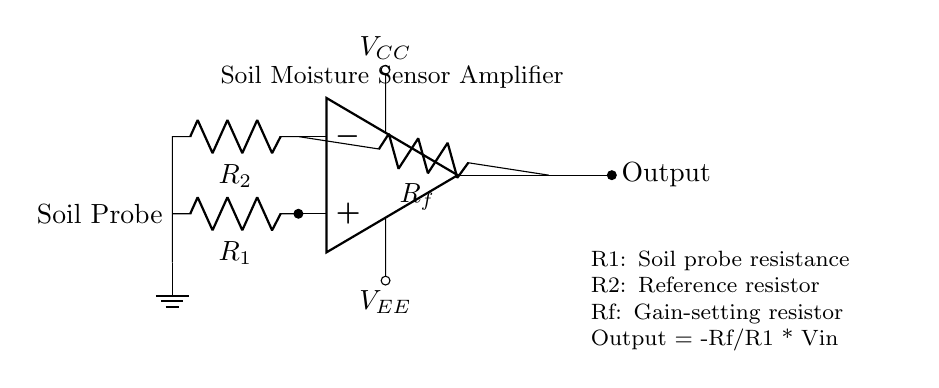What is the function of this circuit? This circuit amplifies the voltage signal from the soil moisture sensor (soil probe) to determine moisture levels. The operational amplifier increases the signal strength to make it readable.
Answer: Amplification What does R1 represent? R1 is labeled as the soil probe resistance, which is affected by the moisture levels in the soil. A lower moisture level results in higher resistance, and vice versa.
Answer: Soil probe resistance What is the role of Rf in the circuit? Rf is the feedback resistor, and it determines the gain of the amplifier based on the relationship between Rf and R1. The output voltage is influenced by the ratio of these resistances.
Answer: Gain-setting resistor How does the output voltage relate to the input voltage? The output voltage is calculated using the formula Output = -Rf/R1 * Vin, indicating that it is the amplified version of the input voltage (Vin) from the soil probe. This relationship shows how amplification depends on Rf and R1.
Answer: Output = -Rf/R1 * Vin What are the supply voltages needed for the op-amp? The circuit requires two power supply voltages: Vcc for the positive side and Vee for the negative side to power the op-amp for proper operation. These supplies are necessary for the functioning of the op-amp.
Answer: Vcc and Vee What happens to the circuit if the soil is very dry? If the soil is very dry, the resistance of the soil probe (R1) increases, resulting in a lower output voltage when calculated with the gain formula. The amplified output will indicate low moisture levels, allowing for monitoring of soil conditions.
Answer: Higher output resistance 